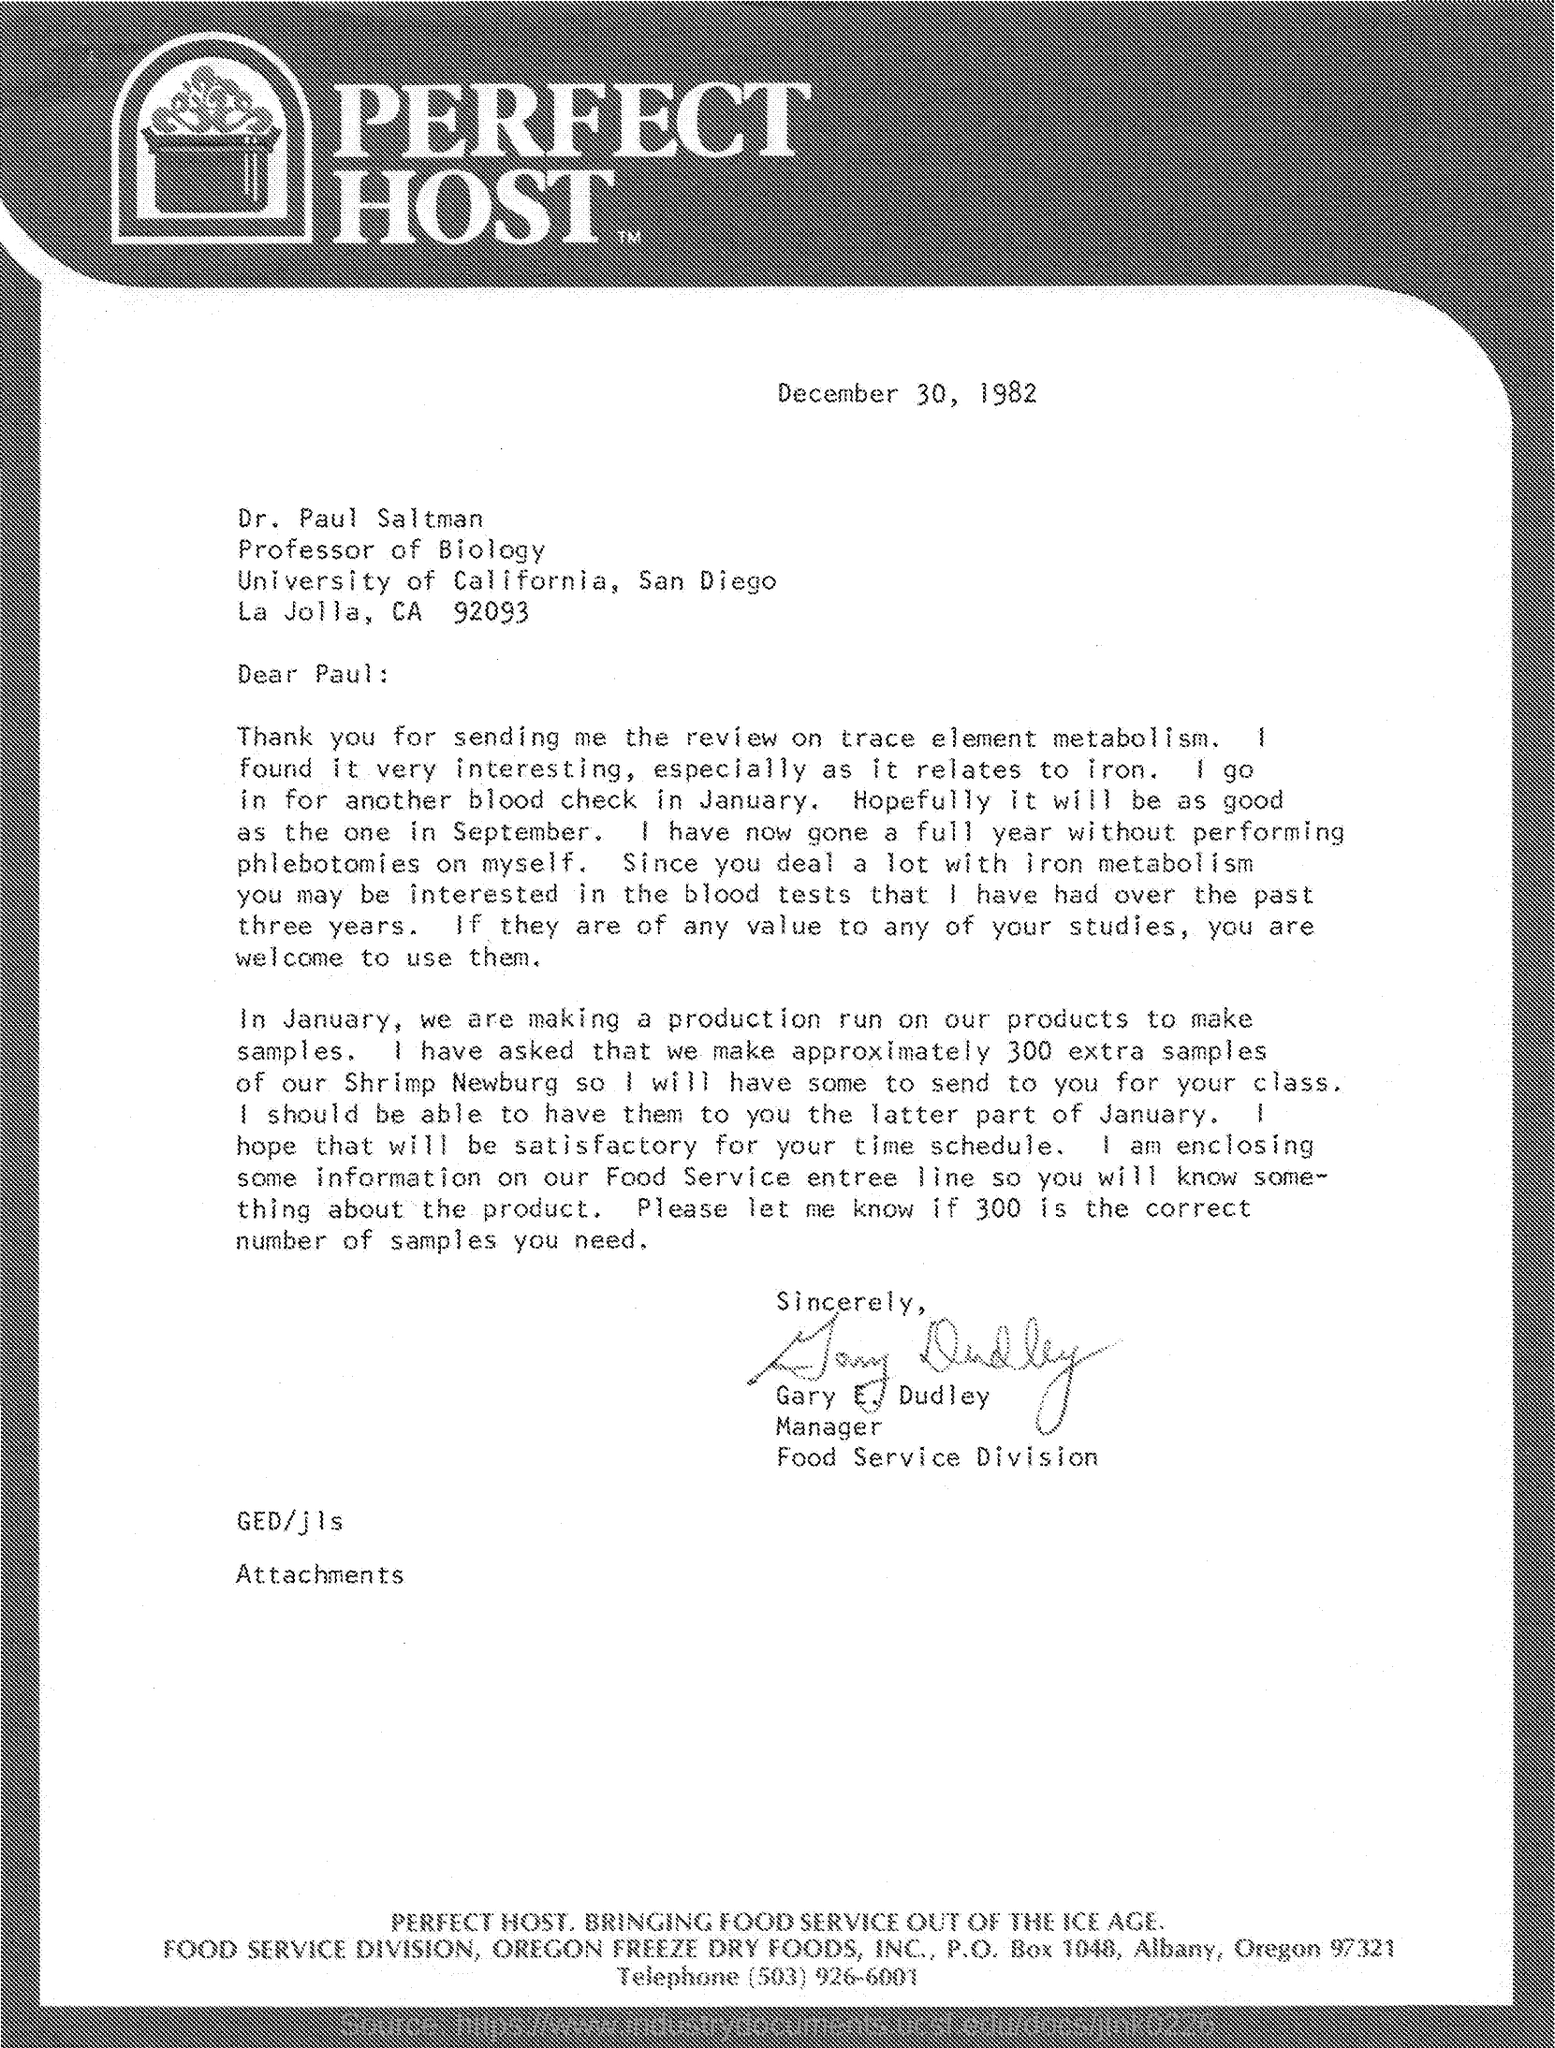What is the date mentioned ?
Make the answer very short. December 30 ,  1982. To whom this letter is written
Offer a very short reply. Dr paul saltman. Who is the manager of food service division
Make the answer very short. Gary E. Dudley. 